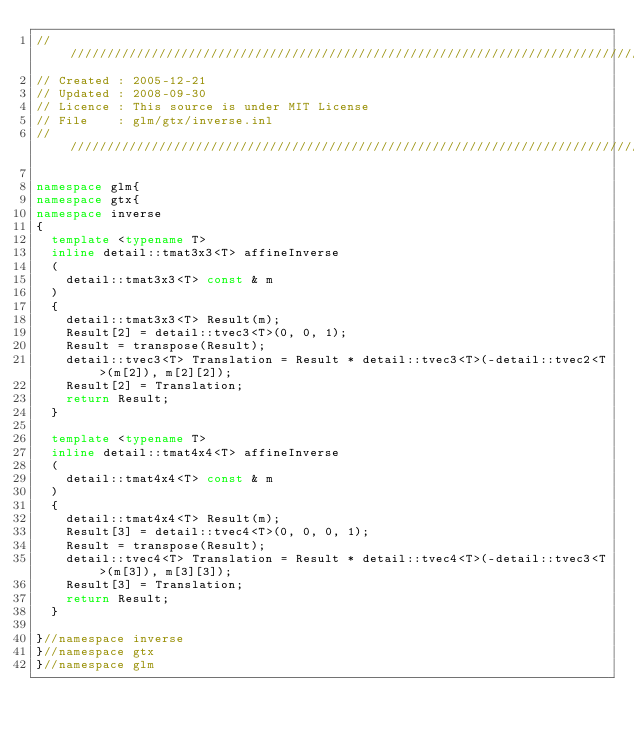<code> <loc_0><loc_0><loc_500><loc_500><_C++_>///////////////////////////////////////////////////////////////////////////////////////////////////
// Created : 2005-12-21
// Updated : 2008-09-30
// Licence : This source is under MIT License
// File    : glm/gtx/inverse.inl
///////////////////////////////////////////////////////////////////////////////////////////////////

namespace glm{
namespace gtx{
namespace inverse
{
	template <typename T> 
	inline detail::tmat3x3<T> affineInverse
	(
		detail::tmat3x3<T> const & m
	)
	{
		detail::tmat3x3<T> Result(m);
		Result[2] = detail::tvec3<T>(0, 0, 1);
		Result = transpose(Result);
		detail::tvec3<T> Translation = Result * detail::tvec3<T>(-detail::tvec2<T>(m[2]), m[2][2]);
		Result[2] = Translation;
		return Result;
	}

	template <typename T> 
	inline detail::tmat4x4<T> affineInverse
	(
		detail::tmat4x4<T> const & m
	)
	{
		detail::tmat4x4<T> Result(m);
		Result[3] = detail::tvec4<T>(0, 0, 0, 1);
		Result = transpose(Result);
		detail::tvec4<T> Translation = Result * detail::tvec4<T>(-detail::tvec3<T>(m[3]), m[3][3]);
		Result[3] = Translation;
		return Result;
	}

}//namespace inverse
}//namespace gtx
}//namespace glm
</code> 